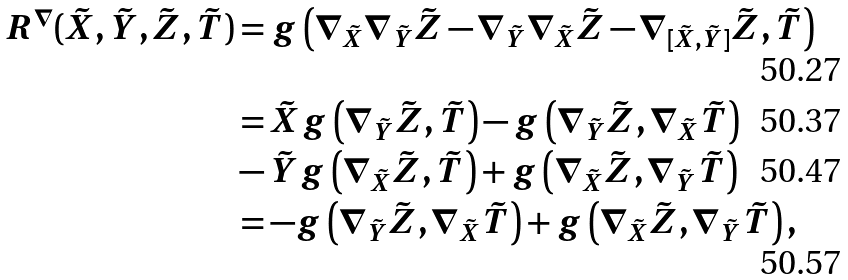Convert formula to latex. <formula><loc_0><loc_0><loc_500><loc_500>R ^ { \nabla } ( \tilde { X } , \tilde { Y } , \tilde { Z } , \tilde { T } ) & = g \left ( \nabla _ { \tilde { X } } \nabla _ { \tilde { Y } } \tilde { Z } - \nabla _ { \tilde { Y } } \nabla _ { \tilde { X } } \tilde { Z } - \nabla _ { [ \tilde { X } , \tilde { Y } ] } \tilde { Z } , \tilde { T } \right ) \\ & = \tilde { X } g \left ( \nabla _ { \tilde { Y } } \tilde { Z } , \tilde { T } \right ) - g \left ( \nabla _ { \tilde { Y } } \tilde { Z } , \nabla _ { \tilde { X } } \tilde { T } \right ) \\ & - \tilde { Y } g \left ( \nabla _ { \tilde { X } } \tilde { Z } , \tilde { T } \right ) + g \left ( \nabla _ { \tilde { X } } \tilde { Z } , \nabla _ { \tilde { Y } } \tilde { T } \right ) \\ & = - g \left ( \nabla _ { \tilde { Y } } \tilde { Z } , \nabla _ { \tilde { X } } \tilde { T } \right ) + g \left ( \nabla _ { \tilde { X } } \tilde { Z } , \nabla _ { \tilde { Y } } \tilde { T } \right ) ,</formula> 